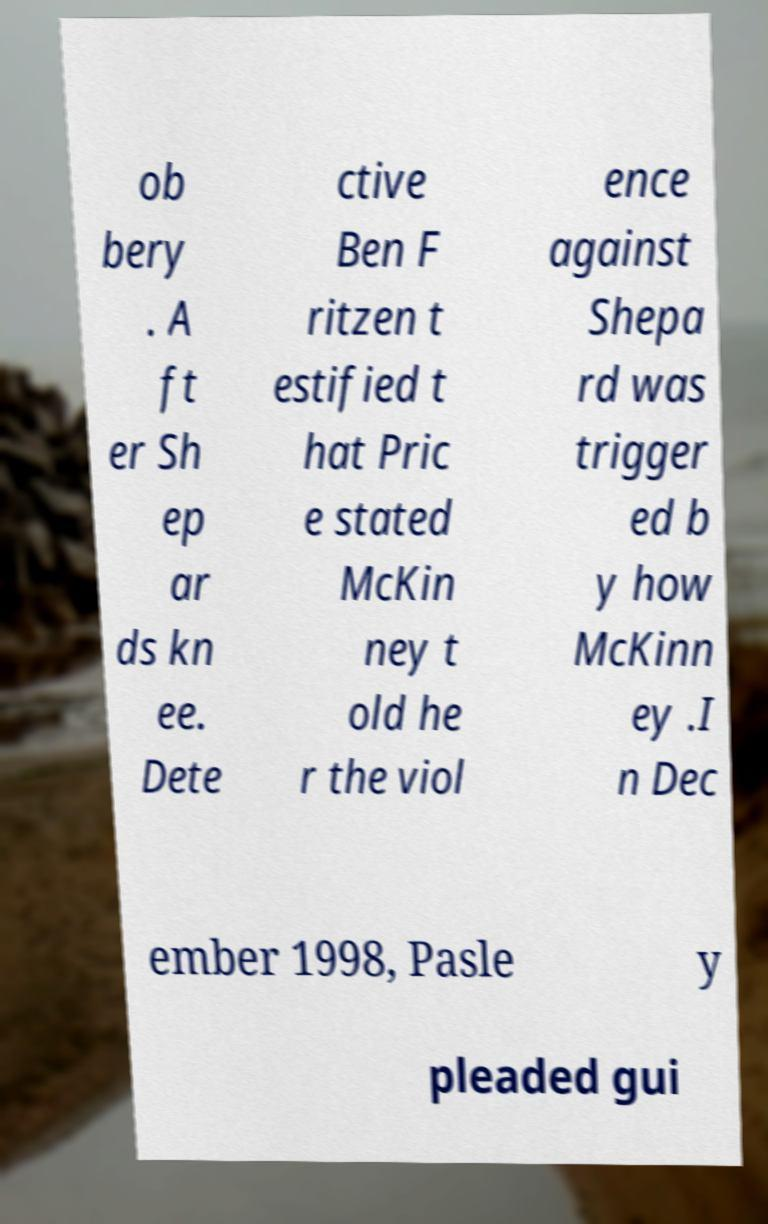What messages or text are displayed in this image? I need them in a readable, typed format. ob bery . A ft er Sh ep ar ds kn ee. Dete ctive Ben F ritzen t estified t hat Pric e stated McKin ney t old he r the viol ence against Shepa rd was trigger ed b y how McKinn ey .I n Dec ember 1998, Pasle y pleaded gui 